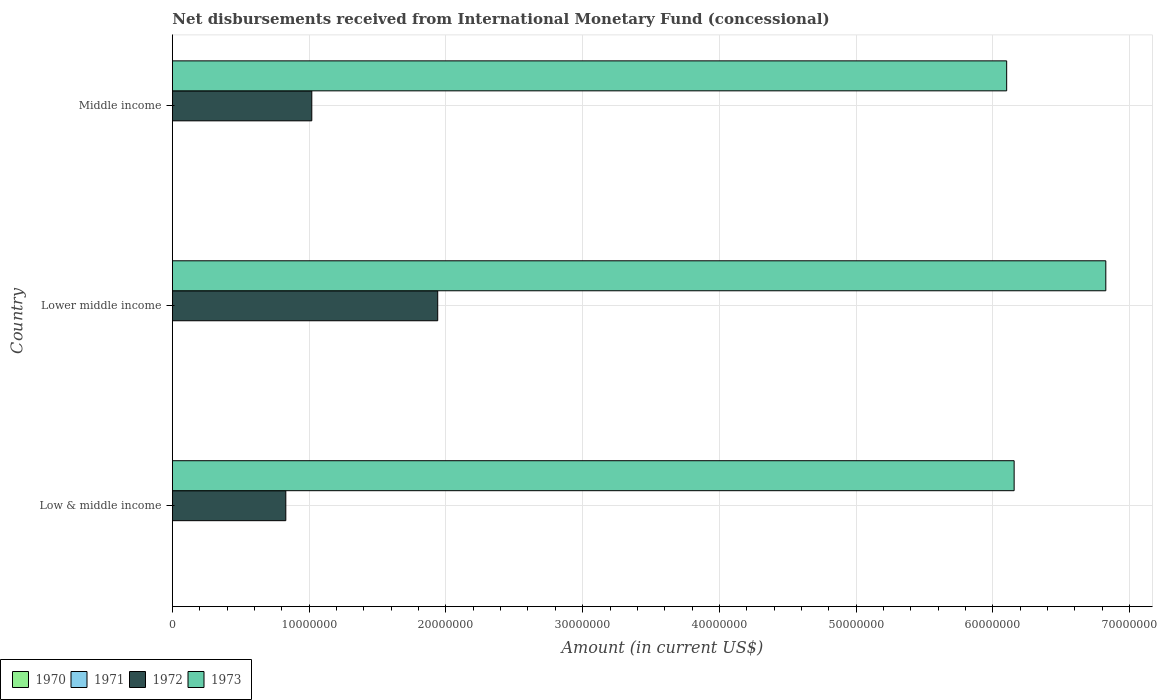Are the number of bars per tick equal to the number of legend labels?
Make the answer very short. No. How many bars are there on the 2nd tick from the top?
Offer a terse response. 2. How many bars are there on the 1st tick from the bottom?
Your answer should be compact. 2. What is the label of the 3rd group of bars from the top?
Your answer should be very brief. Low & middle income. Across all countries, what is the maximum amount of disbursements received from International Monetary Fund in 1973?
Make the answer very short. 6.83e+07. Across all countries, what is the minimum amount of disbursements received from International Monetary Fund in 1971?
Offer a terse response. 0. In which country was the amount of disbursements received from International Monetary Fund in 1973 maximum?
Give a very brief answer. Lower middle income. What is the total amount of disbursements received from International Monetary Fund in 1972 in the graph?
Offer a very short reply. 3.79e+07. What is the difference between the amount of disbursements received from International Monetary Fund in 1973 in Low & middle income and that in Lower middle income?
Ensure brevity in your answer.  -6.70e+06. What is the difference between the amount of disbursements received from International Monetary Fund in 1971 in Middle income and the amount of disbursements received from International Monetary Fund in 1972 in Low & middle income?
Offer a very short reply. -8.30e+06. What is the difference between the amount of disbursements received from International Monetary Fund in 1972 and amount of disbursements received from International Monetary Fund in 1973 in Middle income?
Your answer should be very brief. -5.08e+07. What is the ratio of the amount of disbursements received from International Monetary Fund in 1973 in Lower middle income to that in Middle income?
Provide a succinct answer. 1.12. What is the difference between the highest and the second highest amount of disbursements received from International Monetary Fund in 1973?
Offer a terse response. 6.70e+06. What is the difference between the highest and the lowest amount of disbursements received from International Monetary Fund in 1973?
Make the answer very short. 7.25e+06. Is the sum of the amount of disbursements received from International Monetary Fund in 1973 in Low & middle income and Middle income greater than the maximum amount of disbursements received from International Monetary Fund in 1971 across all countries?
Make the answer very short. Yes. Is it the case that in every country, the sum of the amount of disbursements received from International Monetary Fund in 1970 and amount of disbursements received from International Monetary Fund in 1971 is greater than the amount of disbursements received from International Monetary Fund in 1973?
Keep it short and to the point. No. How many bars are there?
Your response must be concise. 6. How many countries are there in the graph?
Provide a succinct answer. 3. What is the difference between two consecutive major ticks on the X-axis?
Offer a very short reply. 1.00e+07. How many legend labels are there?
Keep it short and to the point. 4. What is the title of the graph?
Your answer should be very brief. Net disbursements received from International Monetary Fund (concessional). What is the label or title of the X-axis?
Ensure brevity in your answer.  Amount (in current US$). What is the label or title of the Y-axis?
Your answer should be compact. Country. What is the Amount (in current US$) in 1971 in Low & middle income?
Your answer should be compact. 0. What is the Amount (in current US$) of 1972 in Low & middle income?
Your answer should be very brief. 8.30e+06. What is the Amount (in current US$) of 1973 in Low & middle income?
Ensure brevity in your answer.  6.16e+07. What is the Amount (in current US$) of 1971 in Lower middle income?
Make the answer very short. 0. What is the Amount (in current US$) in 1972 in Lower middle income?
Ensure brevity in your answer.  1.94e+07. What is the Amount (in current US$) of 1973 in Lower middle income?
Offer a terse response. 6.83e+07. What is the Amount (in current US$) in 1972 in Middle income?
Offer a terse response. 1.02e+07. What is the Amount (in current US$) in 1973 in Middle income?
Offer a very short reply. 6.10e+07. Across all countries, what is the maximum Amount (in current US$) of 1972?
Give a very brief answer. 1.94e+07. Across all countries, what is the maximum Amount (in current US$) in 1973?
Make the answer very short. 6.83e+07. Across all countries, what is the minimum Amount (in current US$) of 1972?
Ensure brevity in your answer.  8.30e+06. Across all countries, what is the minimum Amount (in current US$) in 1973?
Offer a very short reply. 6.10e+07. What is the total Amount (in current US$) of 1972 in the graph?
Provide a short and direct response. 3.79e+07. What is the total Amount (in current US$) of 1973 in the graph?
Your answer should be compact. 1.91e+08. What is the difference between the Amount (in current US$) of 1972 in Low & middle income and that in Lower middle income?
Ensure brevity in your answer.  -1.11e+07. What is the difference between the Amount (in current US$) of 1973 in Low & middle income and that in Lower middle income?
Give a very brief answer. -6.70e+06. What is the difference between the Amount (in current US$) in 1972 in Low & middle income and that in Middle income?
Keep it short and to the point. -1.90e+06. What is the difference between the Amount (in current US$) in 1973 in Low & middle income and that in Middle income?
Your response must be concise. 5.46e+05. What is the difference between the Amount (in current US$) in 1972 in Lower middle income and that in Middle income?
Provide a short and direct response. 9.21e+06. What is the difference between the Amount (in current US$) of 1973 in Lower middle income and that in Middle income?
Make the answer very short. 7.25e+06. What is the difference between the Amount (in current US$) of 1972 in Low & middle income and the Amount (in current US$) of 1973 in Lower middle income?
Provide a succinct answer. -6.00e+07. What is the difference between the Amount (in current US$) of 1972 in Low & middle income and the Amount (in current US$) of 1973 in Middle income?
Keep it short and to the point. -5.27e+07. What is the difference between the Amount (in current US$) of 1972 in Lower middle income and the Amount (in current US$) of 1973 in Middle income?
Your answer should be very brief. -4.16e+07. What is the average Amount (in current US$) in 1970 per country?
Make the answer very short. 0. What is the average Amount (in current US$) in 1972 per country?
Give a very brief answer. 1.26e+07. What is the average Amount (in current US$) of 1973 per country?
Your answer should be compact. 6.36e+07. What is the difference between the Amount (in current US$) of 1972 and Amount (in current US$) of 1973 in Low & middle income?
Your answer should be very brief. -5.33e+07. What is the difference between the Amount (in current US$) in 1972 and Amount (in current US$) in 1973 in Lower middle income?
Your response must be concise. -4.89e+07. What is the difference between the Amount (in current US$) in 1972 and Amount (in current US$) in 1973 in Middle income?
Make the answer very short. -5.08e+07. What is the ratio of the Amount (in current US$) of 1972 in Low & middle income to that in Lower middle income?
Provide a short and direct response. 0.43. What is the ratio of the Amount (in current US$) of 1973 in Low & middle income to that in Lower middle income?
Your response must be concise. 0.9. What is the ratio of the Amount (in current US$) in 1972 in Low & middle income to that in Middle income?
Your answer should be very brief. 0.81. What is the ratio of the Amount (in current US$) of 1972 in Lower middle income to that in Middle income?
Provide a short and direct response. 1.9. What is the ratio of the Amount (in current US$) of 1973 in Lower middle income to that in Middle income?
Provide a short and direct response. 1.12. What is the difference between the highest and the second highest Amount (in current US$) of 1972?
Ensure brevity in your answer.  9.21e+06. What is the difference between the highest and the second highest Amount (in current US$) of 1973?
Your answer should be compact. 6.70e+06. What is the difference between the highest and the lowest Amount (in current US$) in 1972?
Ensure brevity in your answer.  1.11e+07. What is the difference between the highest and the lowest Amount (in current US$) in 1973?
Give a very brief answer. 7.25e+06. 